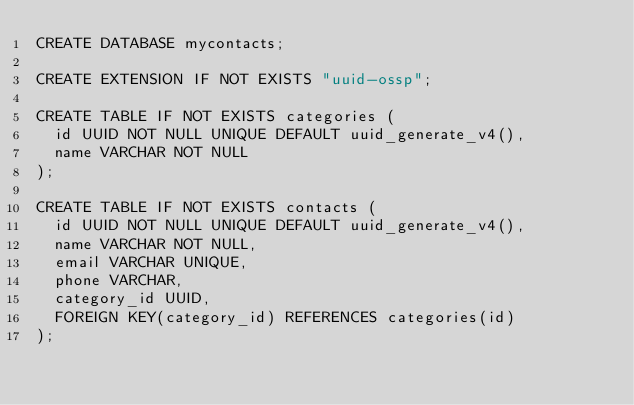<code> <loc_0><loc_0><loc_500><loc_500><_SQL_>CREATE DATABASE mycontacts;

CREATE EXTENSION IF NOT EXISTS "uuid-ossp";

CREATE TABLE IF NOT EXISTS categories (
  id UUID NOT NULL UNIQUE DEFAULT uuid_generate_v4(),
  name VARCHAR NOT NULL
);

CREATE TABLE IF NOT EXISTS contacts (
  id UUID NOT NULL UNIQUE DEFAULT uuid_generate_v4(),
  name VARCHAR NOT NULL,
  email VARCHAR UNIQUE,
  phone VARCHAR,
  category_id UUID,
  FOREIGN KEY(category_id) REFERENCES categories(id)
);</code> 